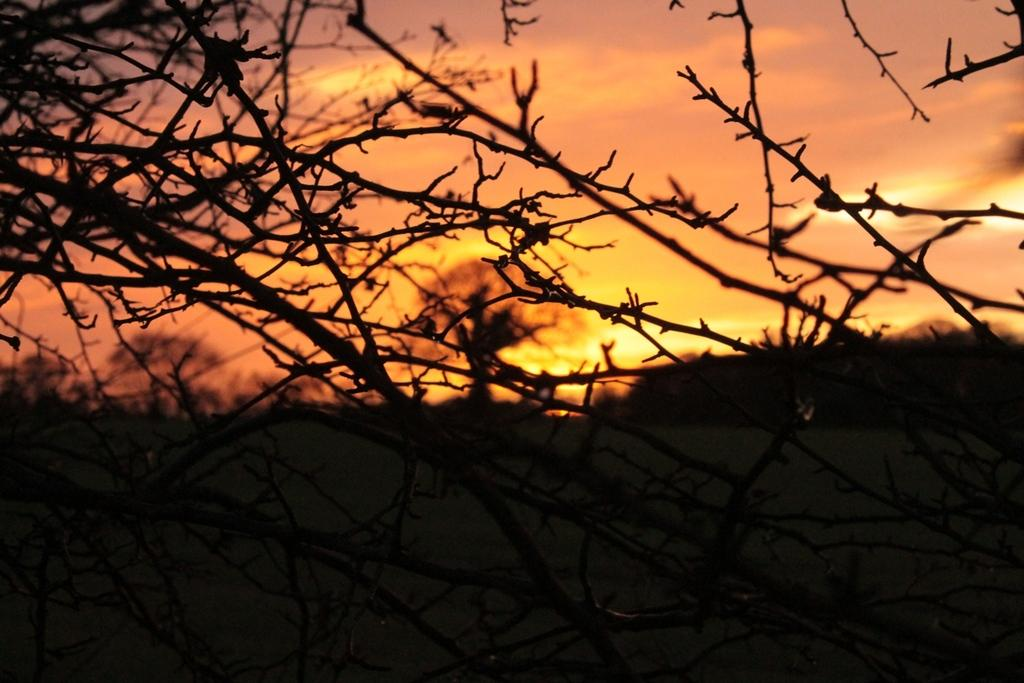What is located in the foreground of the image? There are branches in the foreground of the image. What can be seen in the background of the image? Sky, clouds, and the sun are visible in the background of the image. Can you describe the weather conditions in the image? The presence of clouds and the visible sun suggest it is partly cloudy. What type of crime is being committed in the image? There is no indication of any crime being committed in the image; it features branches and a sky with clouds and the sun. What role does the heart play in the image? There is no heart present in the image. 